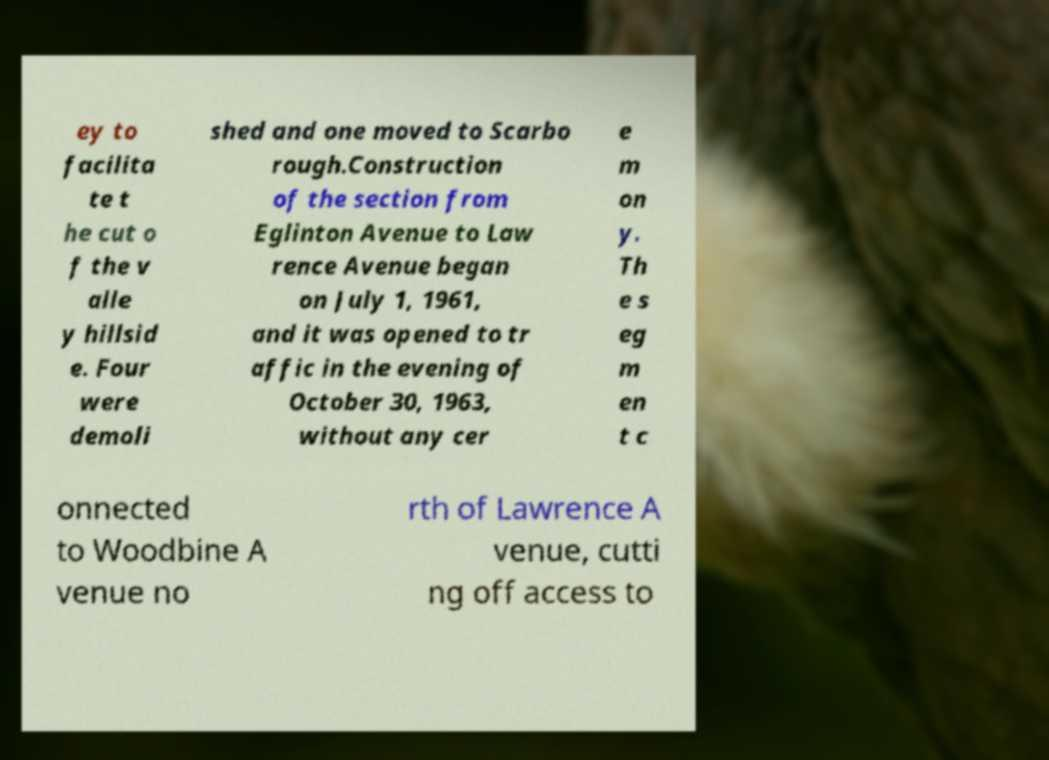Can you read and provide the text displayed in the image?This photo seems to have some interesting text. Can you extract and type it out for me? ey to facilita te t he cut o f the v alle y hillsid e. Four were demoli shed and one moved to Scarbo rough.Construction of the section from Eglinton Avenue to Law rence Avenue began on July 1, 1961, and it was opened to tr affic in the evening of October 30, 1963, without any cer e m on y. Th e s eg m en t c onnected to Woodbine A venue no rth of Lawrence A venue, cutti ng off access to 